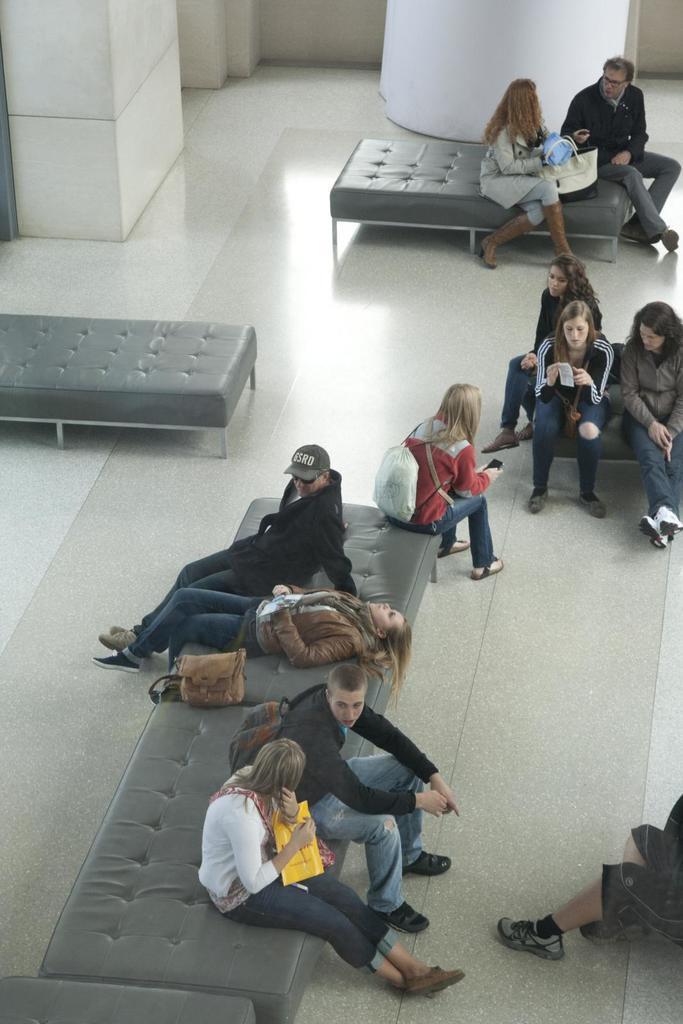Could you give a brief overview of what you see in this image? In this image, we can see some people sitting on the couch and we can see the floor. 